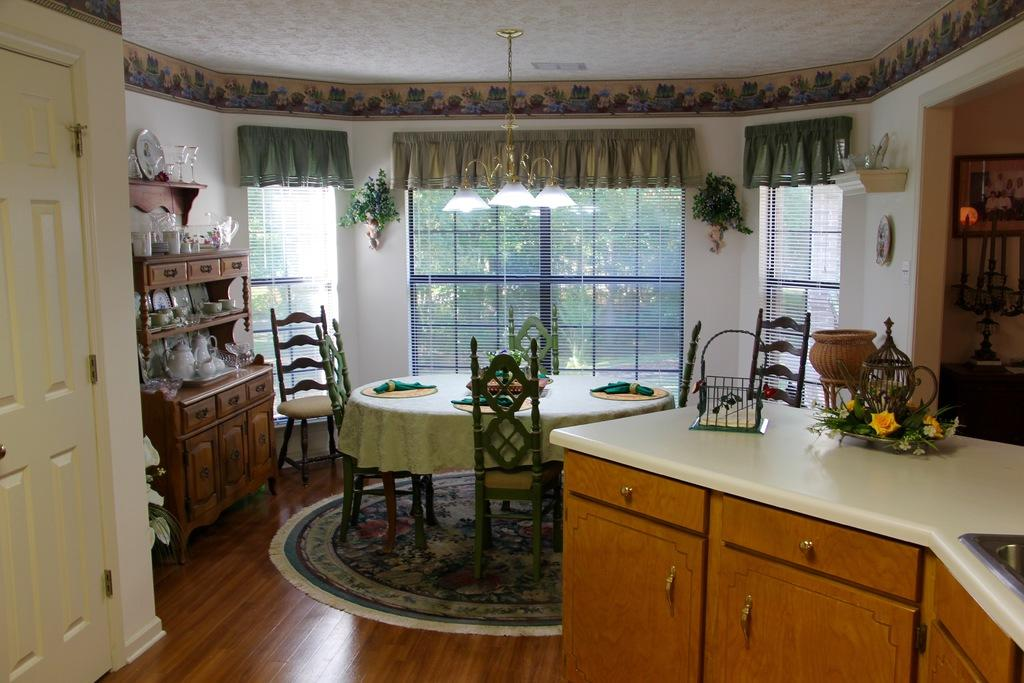What type of structure can be seen in the image? There is a door, a wall, and a window visible in the image. What type of furniture is present in the image? There is a dining table in the image. What is attached to the wall in the image? There is a clock on the wall in the image. What type of prose is being recited by the expert in the image? There is no expert or prose present in the image; it only features a door, a wall, a window, a dining table, and a clock on the wall. 